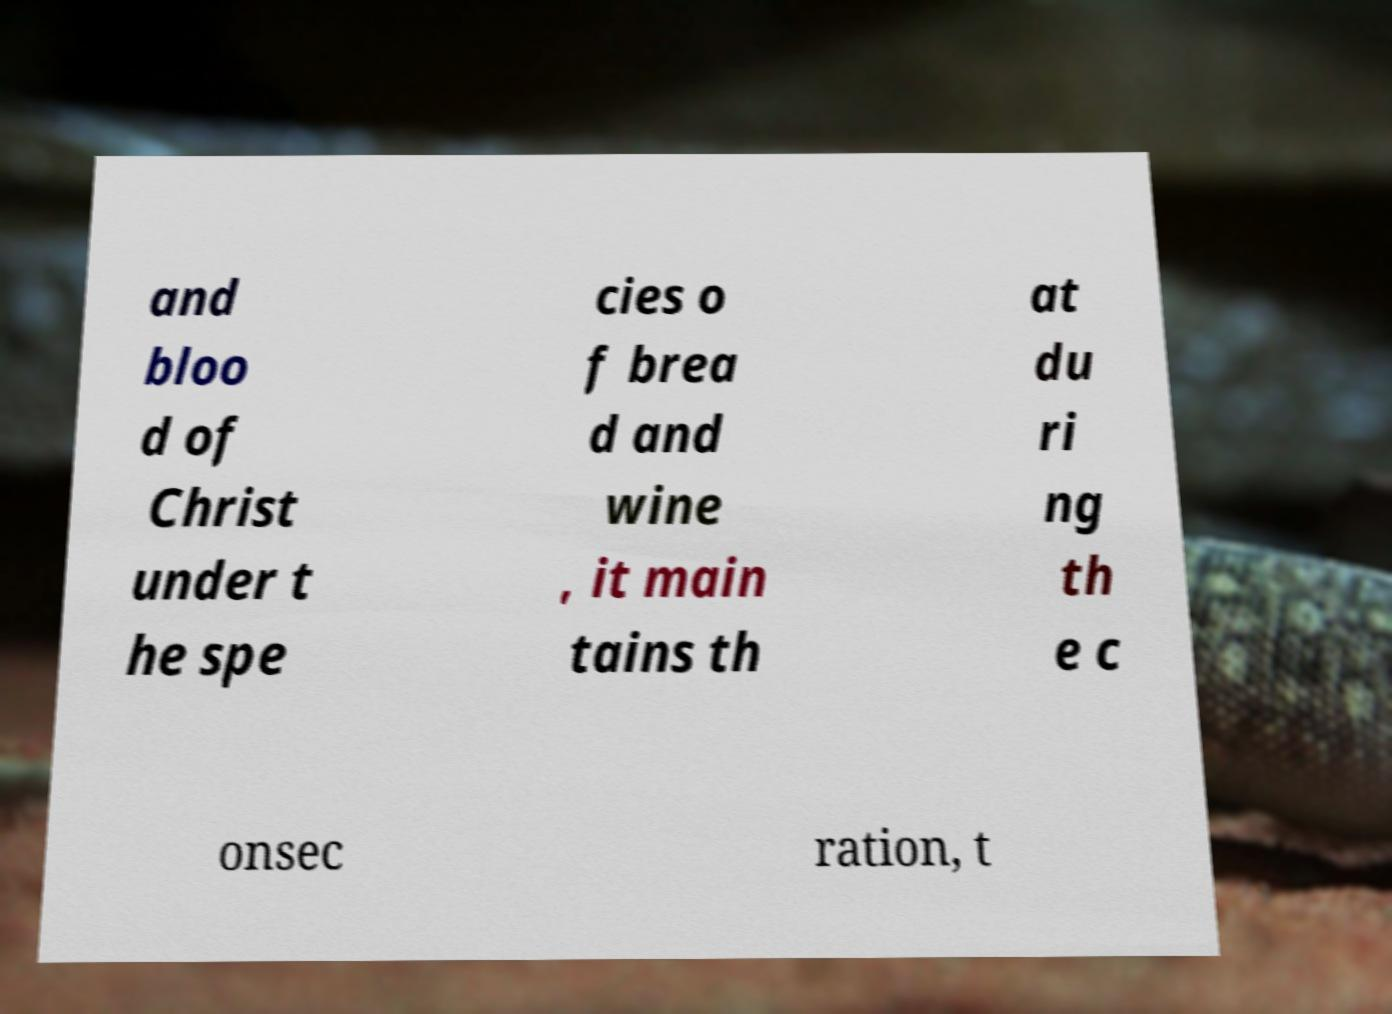What messages or text are displayed in this image? I need them in a readable, typed format. and bloo d of Christ under t he spe cies o f brea d and wine , it main tains th at du ri ng th e c onsec ration, t 